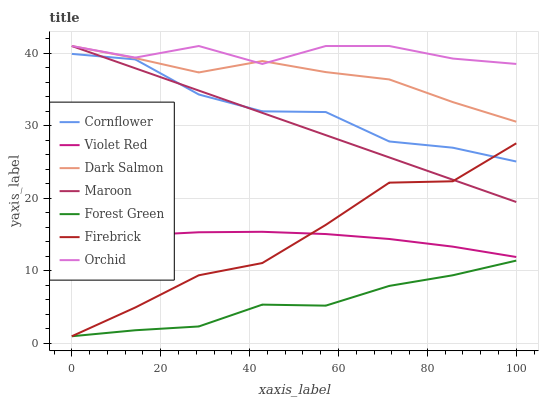Does Forest Green have the minimum area under the curve?
Answer yes or no. Yes. Does Orchid have the maximum area under the curve?
Answer yes or no. Yes. Does Violet Red have the minimum area under the curve?
Answer yes or no. No. Does Violet Red have the maximum area under the curve?
Answer yes or no. No. Is Maroon the smoothest?
Answer yes or no. Yes. Is Firebrick the roughest?
Answer yes or no. Yes. Is Violet Red the smoothest?
Answer yes or no. No. Is Violet Red the roughest?
Answer yes or no. No. Does Violet Red have the lowest value?
Answer yes or no. No. Does Orchid have the highest value?
Answer yes or no. Yes. Does Violet Red have the highest value?
Answer yes or no. No. Is Violet Red less than Cornflower?
Answer yes or no. Yes. Is Orchid greater than Cornflower?
Answer yes or no. Yes. Does Orchid intersect Maroon?
Answer yes or no. Yes. Is Orchid less than Maroon?
Answer yes or no. No. Is Orchid greater than Maroon?
Answer yes or no. No. Does Violet Red intersect Cornflower?
Answer yes or no. No. 